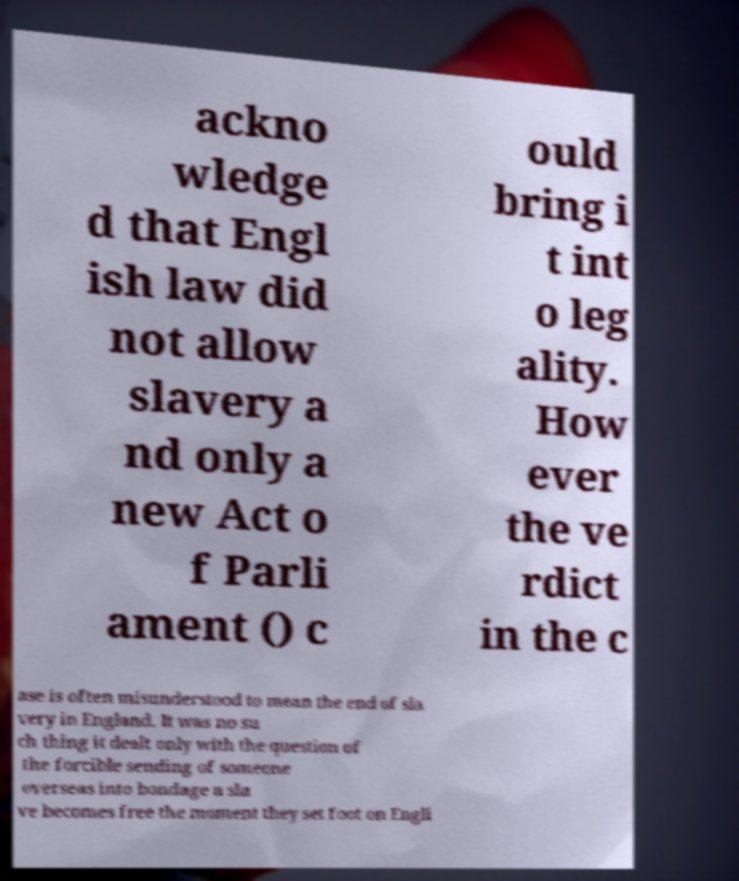Please read and relay the text visible in this image. What does it say? ackno wledge d that Engl ish law did not allow slavery a nd only a new Act o f Parli ament () c ould bring i t int o leg ality. How ever the ve rdict in the c ase is often misunderstood to mean the end of sla very in England. It was no su ch thing it dealt only with the question of the forcible sending of someone overseas into bondage a sla ve becomes free the moment they set foot on Engli 